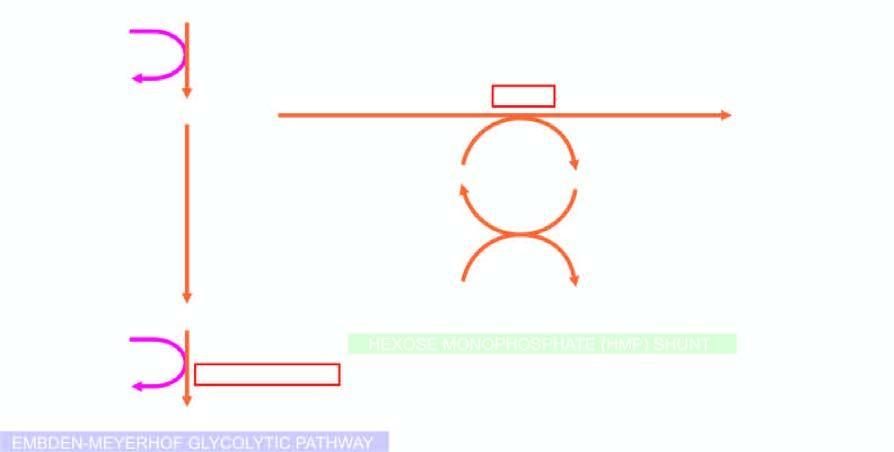what are shown bold?
Answer the question using a single word or phrase. The two red cell enzyme defects 